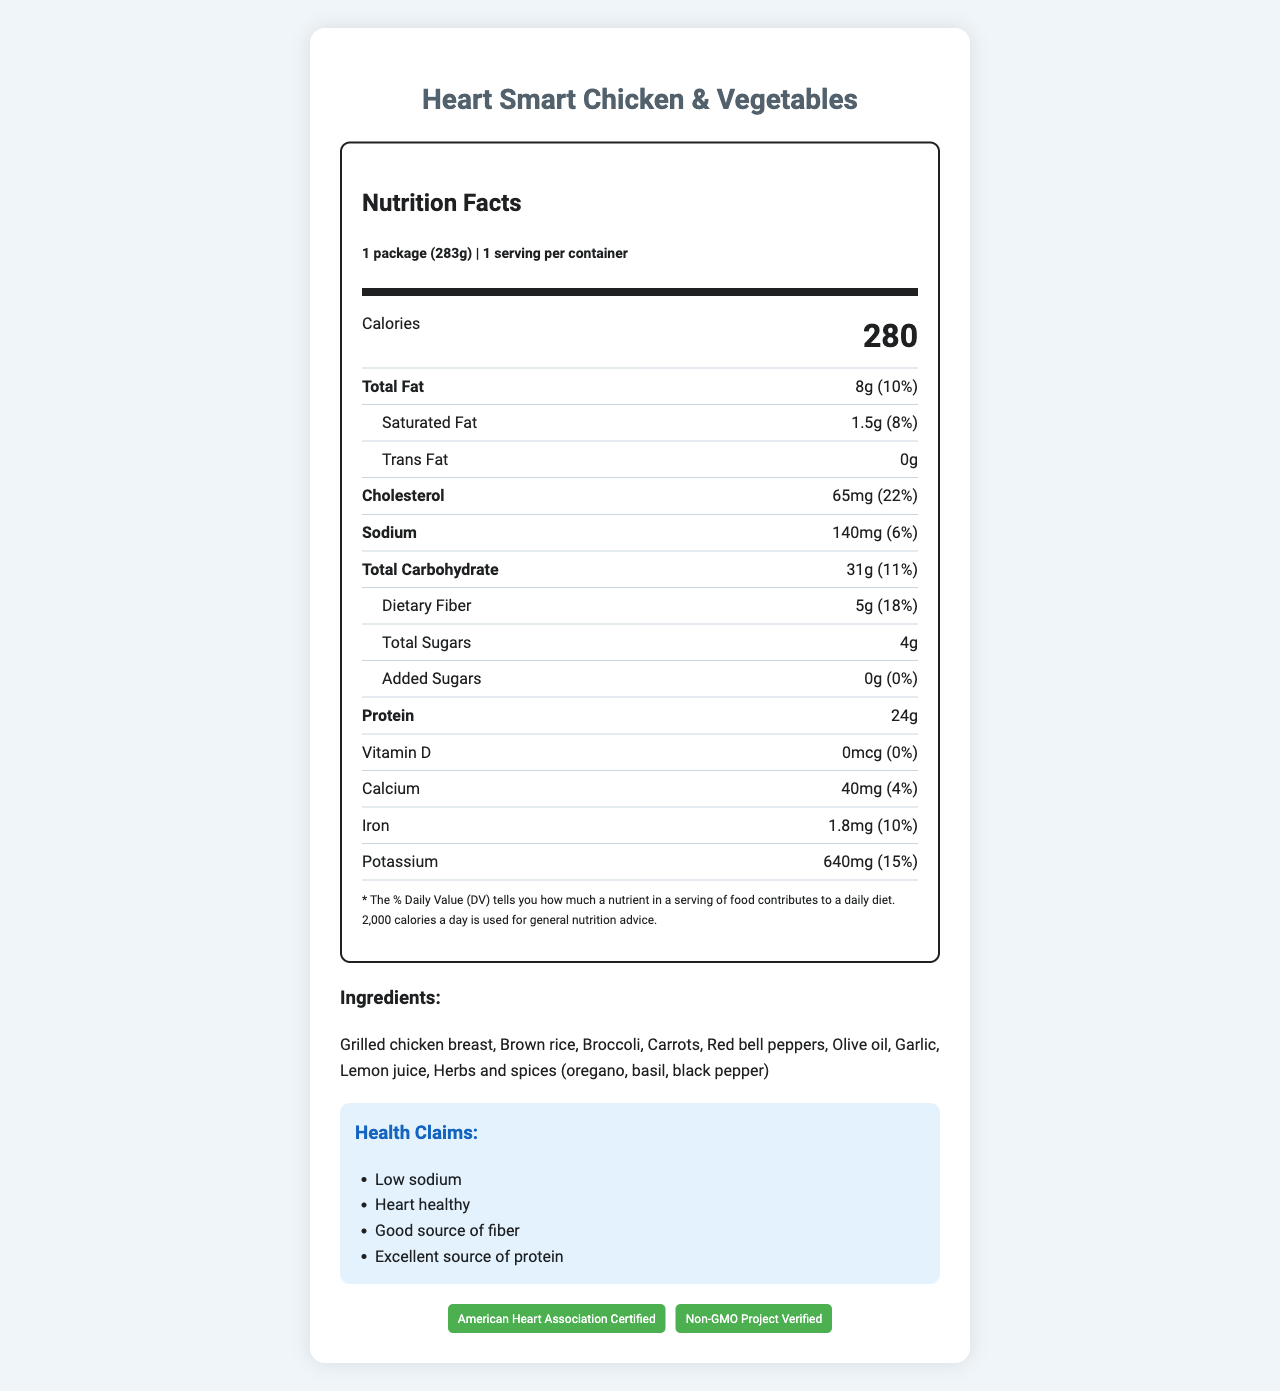how many calories are in one serving size? The label states that each serving size, which is 1 package or 283 grams, contains 280 calories.
Answer: 280 what is the serving size of the Heart Smart Chicken & Vegetables? The label specifies that the serving size is 1 package, which is equivalent to 283 grams.
Answer: 1 package (283g) how much sodium is in the frozen dinner? The nutrition facts indicate that the total sodium in one serving is 140mg, which is 6% of the daily value.
Answer: 140mg what percentage of daily value is the total fat? According to the nutrition facts, the total fat content is 8g, which represents 10% of the daily value.
Answer: 10% what are the top three ingredients listed on the label? The ingredients are listed in order of predominance: Grilled chicken breast, Brown rice, and Broccoli are the first three.
Answer: Grilled chicken breast, Brown rice, Broccoli which nutrient has the highest percent daily value in the serving? A. Sodium B. Dietary Fiber C. Iron D. Cholesterol Cholesterol has the highest percent daily value at 22%, followed by Dietary Fiber at 18%.
Answer: D what is the calorie count of Heart Smart Chicken & Vegetables per package? A. 150 B. 235 C. 280 D. 310 The label clearly states that the calorie count per package is 280.
Answer: C is this product a good source of protein? The product is labeled as an excellent source of protein and contains 24g of protein per serving.
Answer: Yes is there any added sugar in this product? The nutrition label shows 0g of added sugars, reflecting 0% of the daily value.
Answer: No how do you prepare the Heart Smart Chicken & Vegetables? The preparation instructions specify microwaving the package on high for 3-4 minutes and then letting it stand for 1 minute before serving.
Answer: Microwave on high for 3-4 minutes. Let stand for 1 minute before serving. describe the main idea of this document. This description summarizes all the key sections presented in the document, covering nutritional content, ingredients, preparation instructions, and certifications.
Answer: The document provides detailed nutrition facts and other relevant information about the Heart Smart Chicken & Vegetables frozen dinner. It includes information about the serving size, calorie count, nutrient content, ingredients, health claims, preparation, storage instructions, and certifications. what is the production date of the Heart Smart Chicken & Vegetables? The document does not provide any details regarding the production date of the product.
Answer: Not enough information 